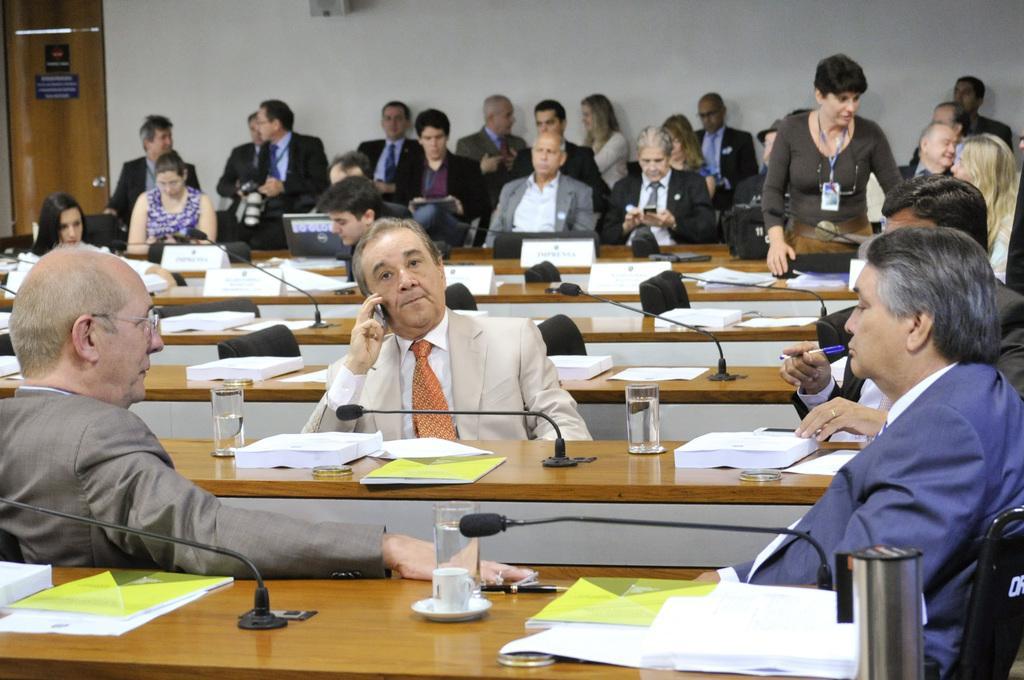Please provide a concise description of this image. There is a group of persons sitting on the chairs. There are glasses, papers and Mics are present on the tables as we can in the middle of this image. There is a white color wall in the background. There is a door at the top left corner of this image. The person sitting in the middle is holding a mobile. 